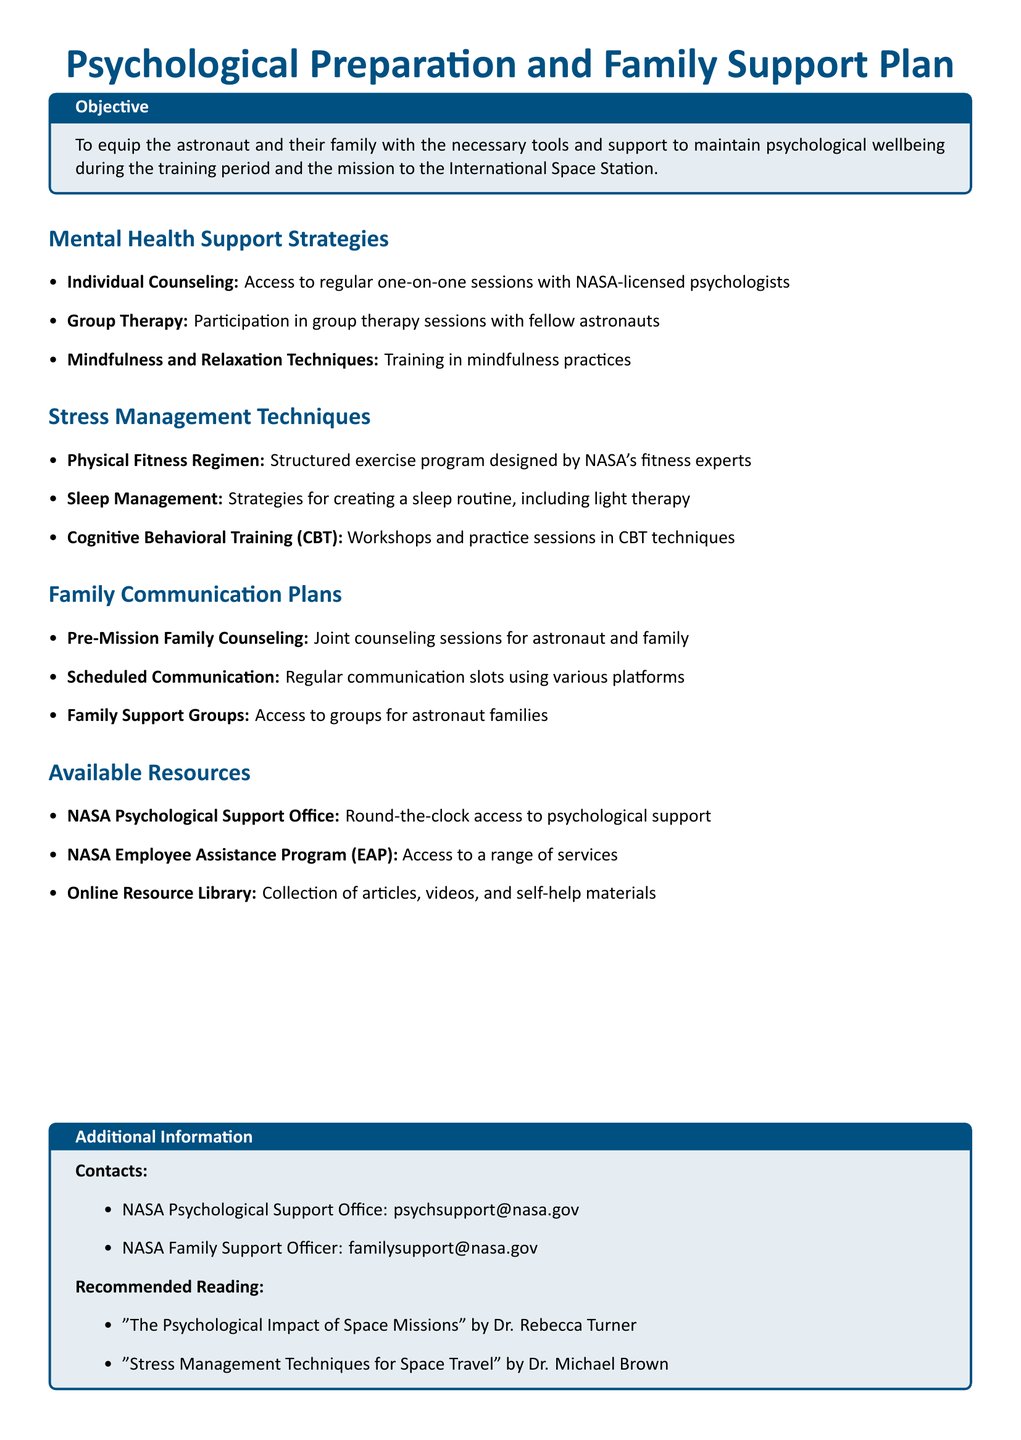What is the objective of the Psychological Preparation and Family Support Plan? The objective is to equip the astronaut and their family with the necessary tools and support to maintain psychological wellbeing during the training period and the mission to the International Space Station.
Answer: To equip the astronaut and their family with the necessary tools and support to maintain psychological wellbeing during the training period and the mission to the International Space Station How many types of mental health support strategies are listed? The document lists three types of mental health support strategies under the "Mental Health Support Strategies" section.
Answer: Three What technique is included for stress management? The stress management techniques listed include strategies like creating a sleep routine.
Answer: Sleep Management Which program offers round-the-clock psychological support? The resource that offers round-the-clock psychological support is mentioned as NASA Psychological Support Office.
Answer: NASA Psychological Support Office What is the email for the NASA Family Support Officer? The email provided for the NASA Family Support Officer is mentioned in the "Contacts" section.
Answer: familysupport@nasa.gov What type of counseling is available for families before the mission? The document mentions that there are joint counseling sessions available for astronaut and family as pre-mission counseling.
Answer: Pre-Mission Family Counseling How many resources are listed under "Available Resources"? There are three resources listed under the "Available Resources" section of the document.
Answer: Three What is one book recommended for reading? The document highlights a specific book in the "Recommended Reading" section that discusses the psychological impact of space missions.
Answer: "The Psychological Impact of Space Missions" by Dr. Rebecca Turner 